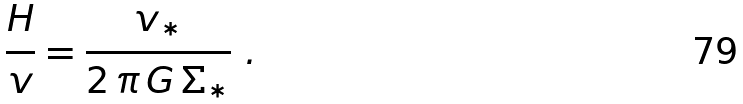Convert formula to latex. <formula><loc_0><loc_0><loc_500><loc_500>\frac { H } { v } = \frac { v _ { * } } { 2 \, \pi \, G \, \Sigma _ { * } } \ .</formula> 